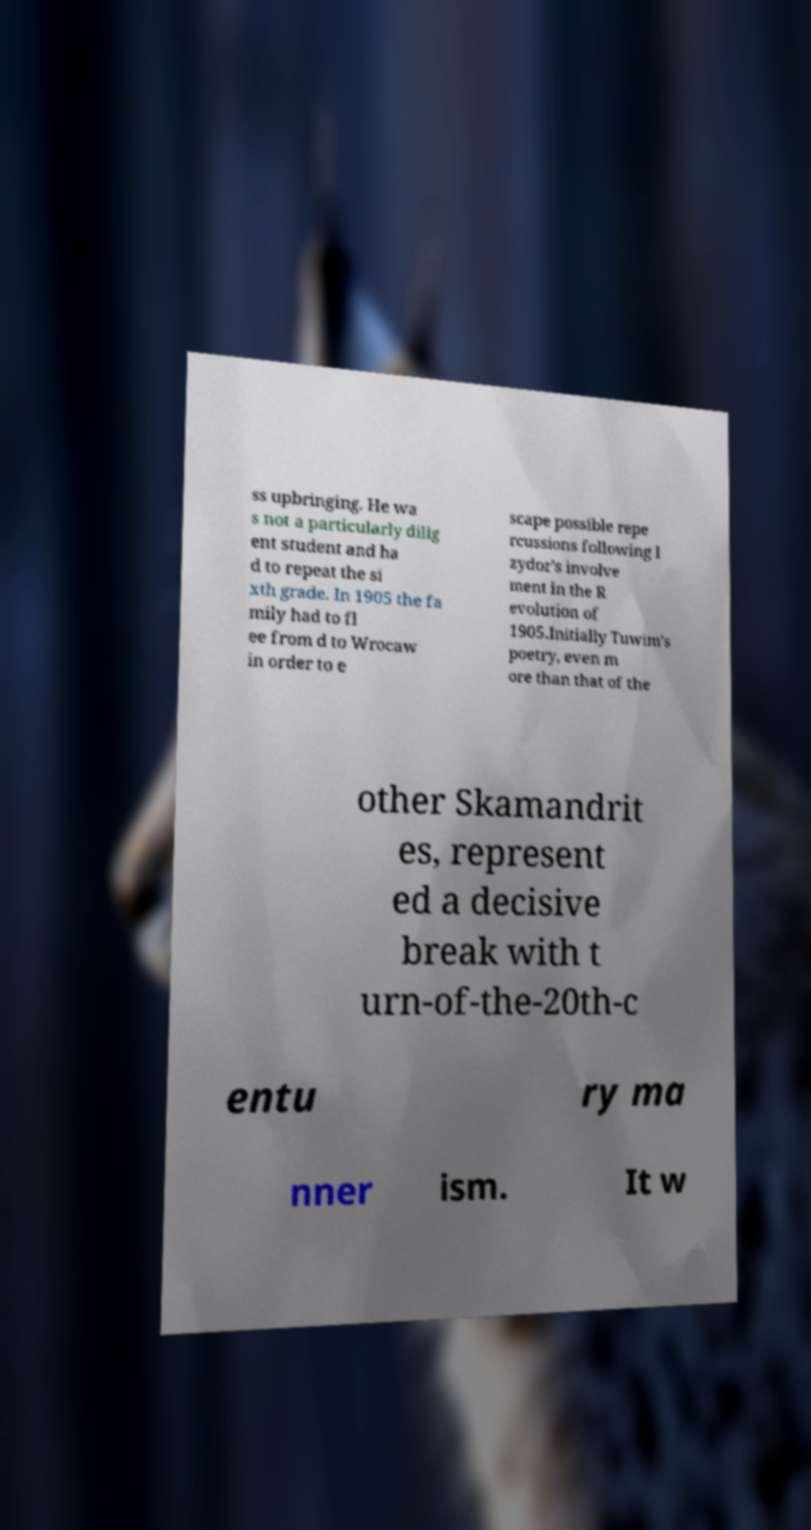There's text embedded in this image that I need extracted. Can you transcribe it verbatim? ss upbringing. He wa s not a particularly dilig ent student and ha d to repeat the si xth grade. In 1905 the fa mily had to fl ee from d to Wrocaw in order to e scape possible repe rcussions following I zydor's involve ment in the R evolution of 1905.Initially Tuwim's poetry, even m ore than that of the other Skamandrit es, represent ed a decisive break with t urn-of-the-20th-c entu ry ma nner ism. It w 